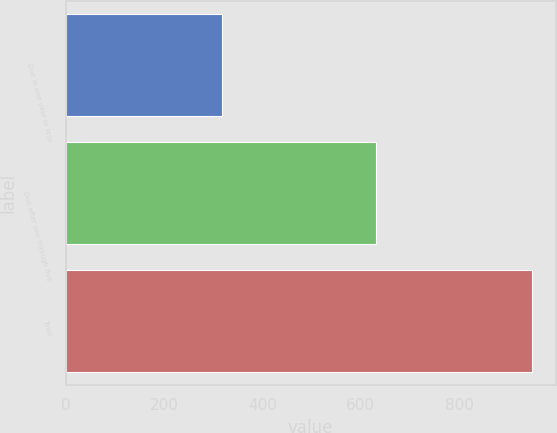<chart> <loc_0><loc_0><loc_500><loc_500><bar_chart><fcel>Due in one year or less<fcel>Due after one through five<fcel>Total<nl><fcel>318<fcel>631<fcel>949<nl></chart> 